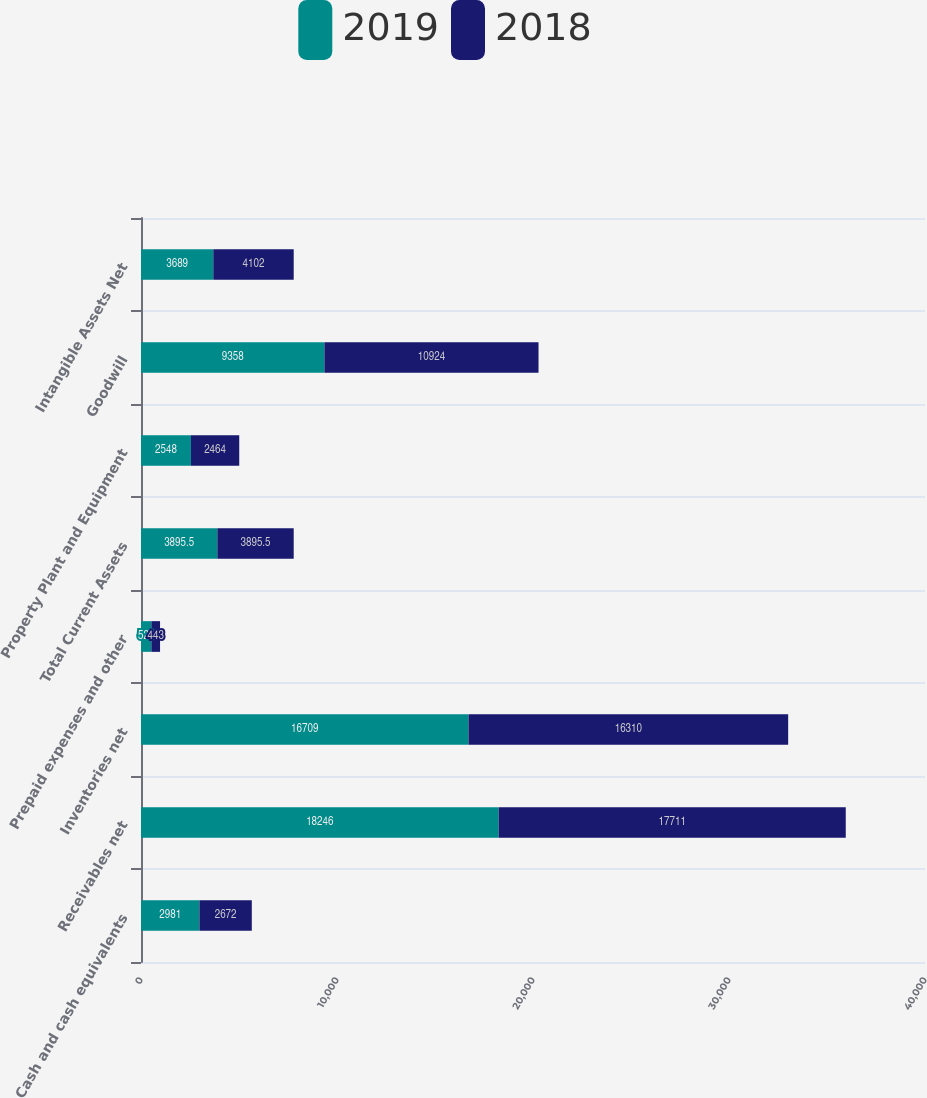Convert chart. <chart><loc_0><loc_0><loc_500><loc_500><stacked_bar_chart><ecel><fcel>Cash and cash equivalents<fcel>Receivables net<fcel>Inventories net<fcel>Prepaid expenses and other<fcel>Total Current Assets<fcel>Property Plant and Equipment<fcel>Goodwill<fcel>Intangible Assets Net<nl><fcel>2019<fcel>2981<fcel>18246<fcel>16709<fcel>529<fcel>3895.5<fcel>2548<fcel>9358<fcel>3689<nl><fcel>2018<fcel>2672<fcel>17711<fcel>16310<fcel>443<fcel>3895.5<fcel>2464<fcel>10924<fcel>4102<nl></chart> 